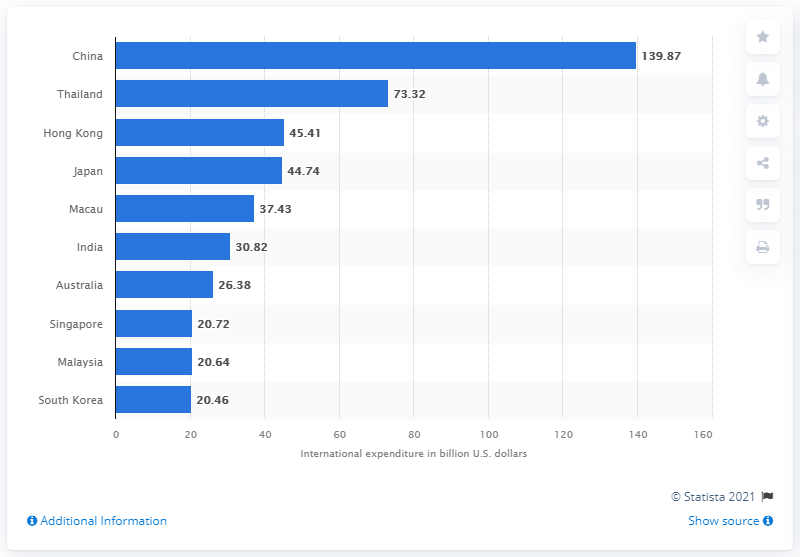List a handful of essential elements in this visual. In 2019, China was the country in the Asia Pacific region with the highest amount of international visitor spending. South Korea's tourism expenditure in 2019 was 20.64. According to the data, in 2019, the amount of international tourism expenditure in China reached 139.87 in US dollars. 